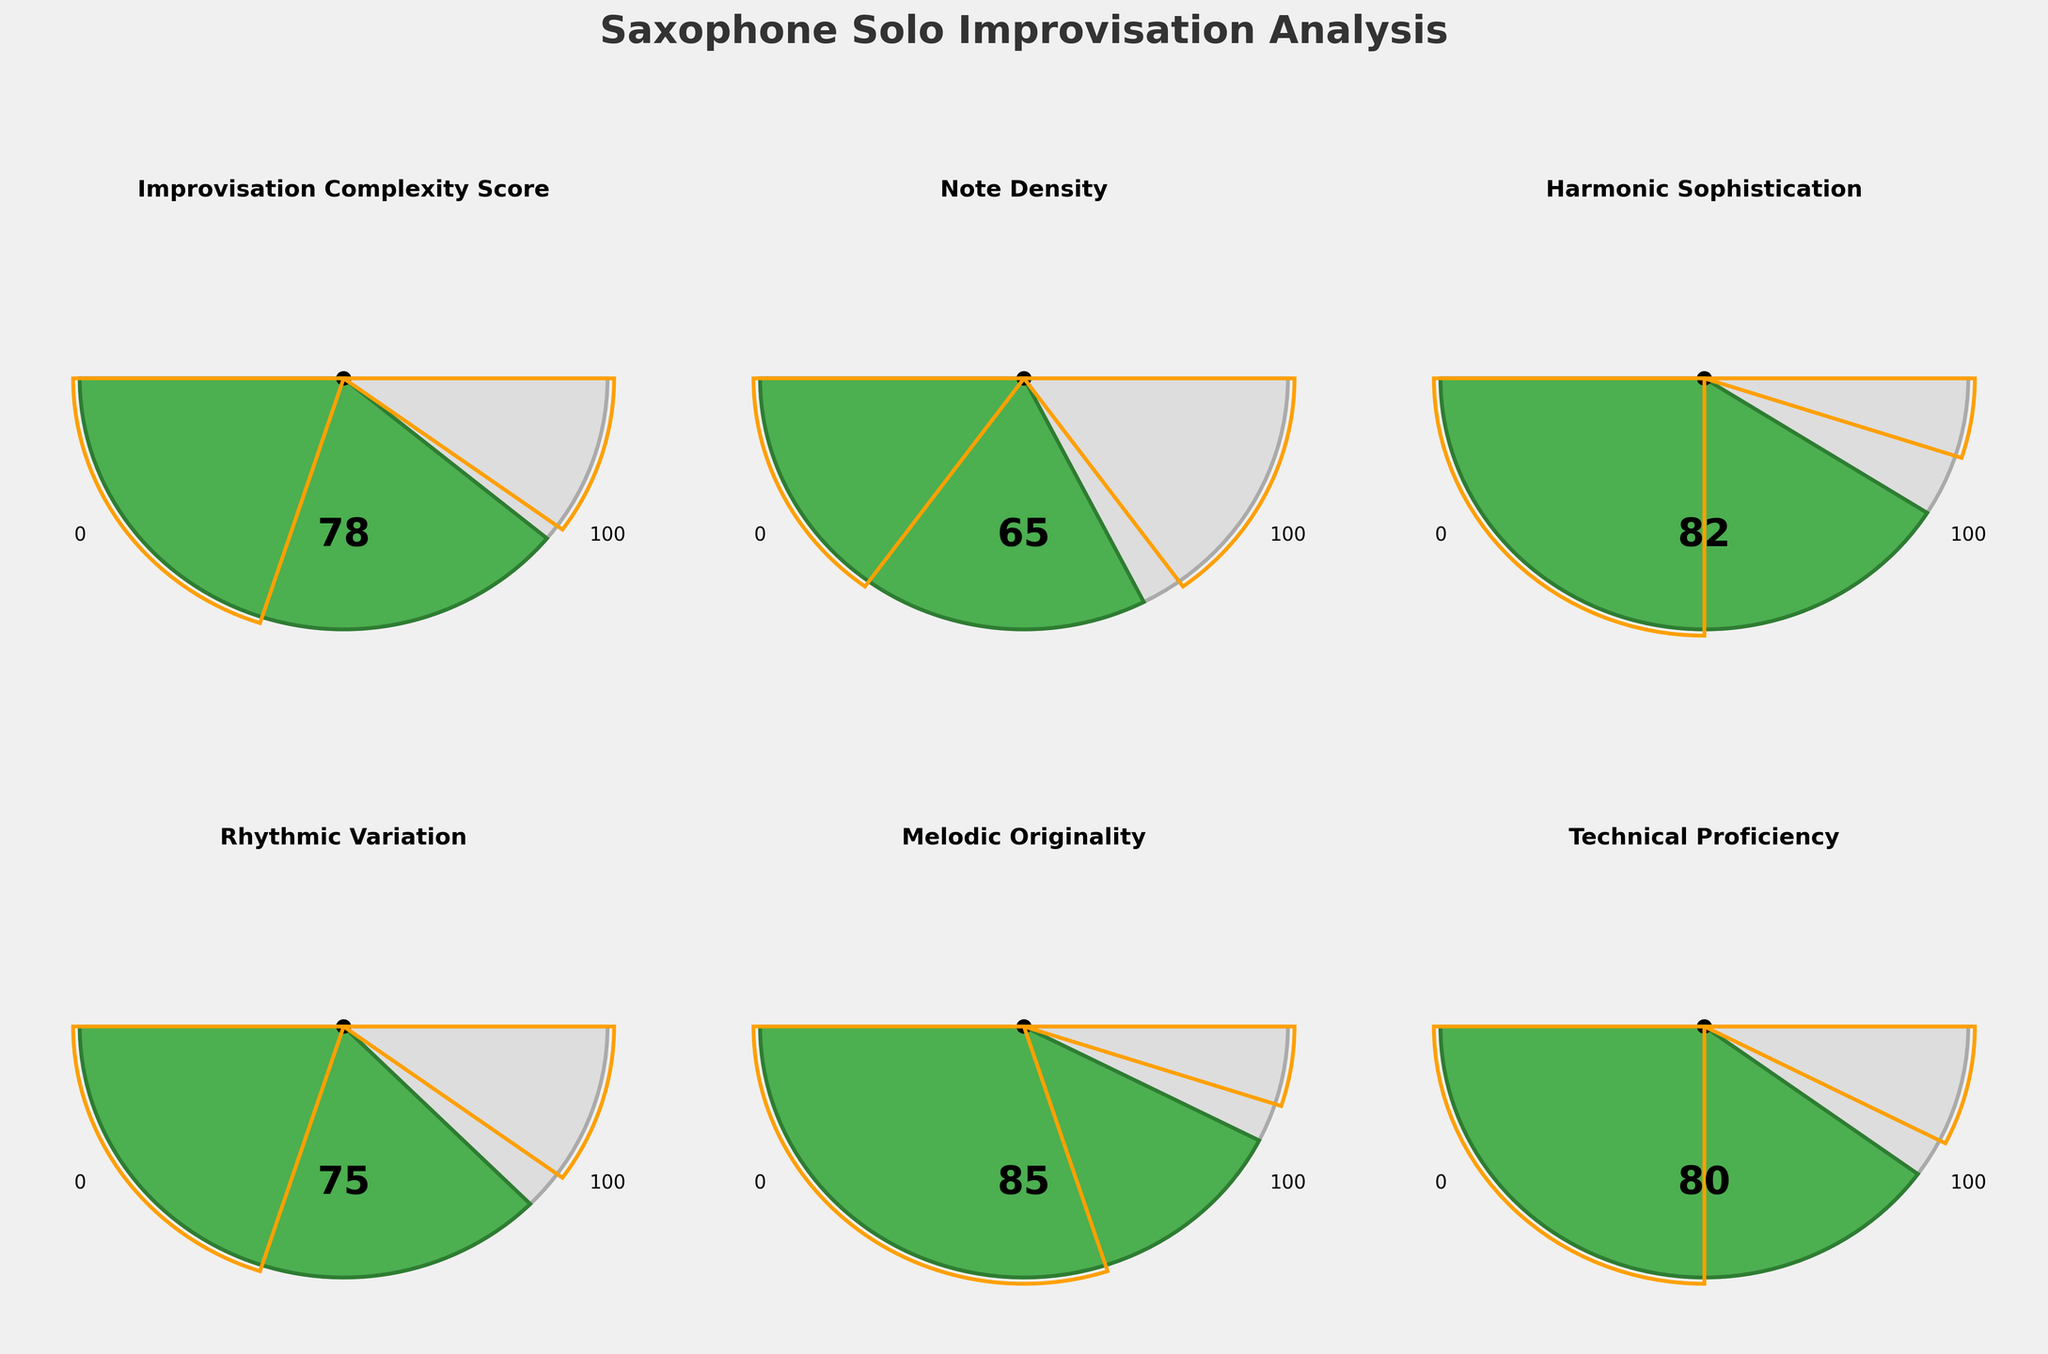What is the title of the figure? The title is usually displayed prominently at the top of the plot. In this case, it is written at the top and it’s "Saxophone Solo Improvisation Analysis."
Answer: Saxophone Solo Improvisation Analysis What does the highest score on the "Improvisation Complexity Score" gauge represent? The highest value on the gauge is where the needle points furthest from the center, near the upper limit marked as 100.
Answer: 100 Which metric has the lowest score? By looking at where the needle points on each gauge, the metric with the lowest value is "Note Density" with a score of 65.
Answer: Note Density Which metric has the highest score? Observe all the gauges; the metric with the highest value is "Melodic Originality" with a score of 85.
Answer: Melodic Originality What is the range of "Harmonic Sophistication"? The range is specified by the minimum and maximum values, which are 0 and 100, respectively.
Answer: 0 to 100 Is the "Technical Proficiency" score higher or lower than the "Rhythmic Variation" score? Compare the scores on the gauges; "Technical Proficiency" is 80, and "Rhythmic Variation" is 75.
Answer: Higher Which metric fall outside its 'High' range and what are those values? Compare the values of all metrics against their 'High' range: "Harmonic Sophistication" (82, High is 90) and "Melodic Originality" (85, High is 90) are within range. Others fall inside their respective ranges.
Answer: None How many metrics lie exactly within their "Low" to "High" range? Compare each value with its respective 'Low' and 'High' ranges: All metrics are within the range specified.
Answer: All 6 metrics Which metric has the smallest gap between its score value and its "High" range? Calculate the difference between each metric's value and its 'High' range: "Technical Proficiency" (85 - 80 = 5).
Answer: Technical Proficiency Are any metrics within their 'Low' range? Check if any metric value is in the specified 'Low' range: No, all are above their respective 'Low' ranges.
Answer: No 